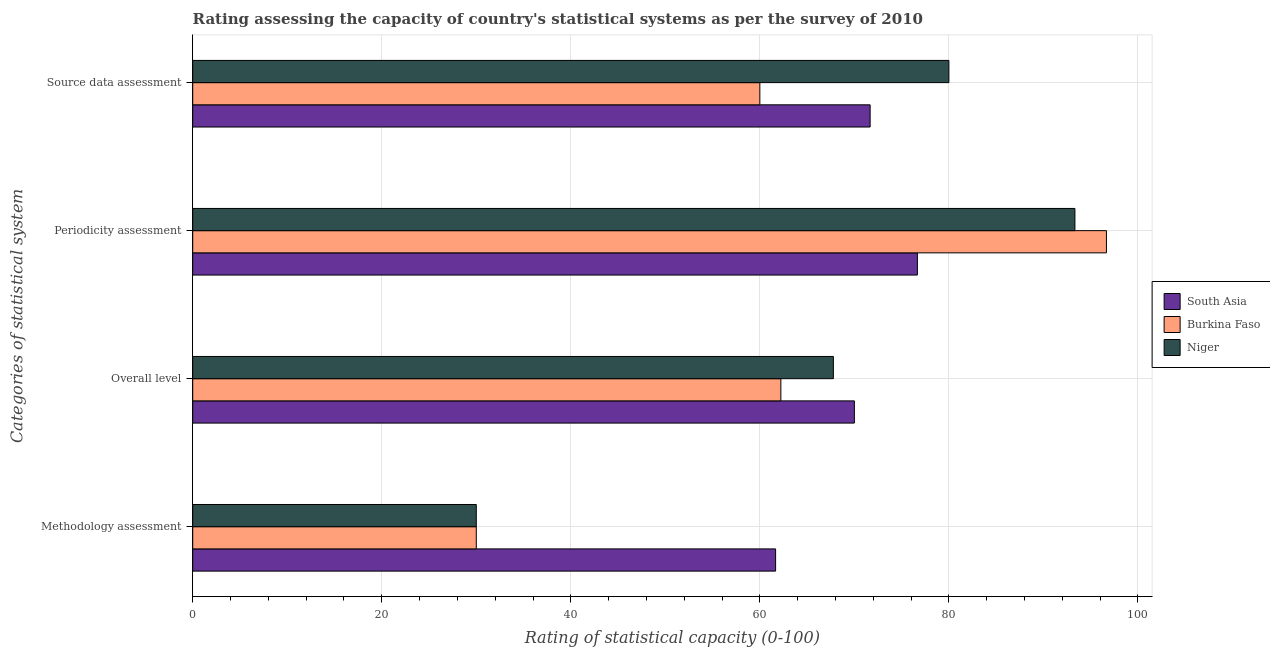How many different coloured bars are there?
Keep it short and to the point. 3. How many bars are there on the 4th tick from the bottom?
Offer a very short reply. 3. What is the label of the 3rd group of bars from the top?
Your answer should be very brief. Overall level. Across all countries, what is the maximum periodicity assessment rating?
Make the answer very short. 96.67. Across all countries, what is the minimum overall level rating?
Ensure brevity in your answer.  62.22. In which country was the overall level rating maximum?
Ensure brevity in your answer.  South Asia. In which country was the overall level rating minimum?
Provide a succinct answer. Burkina Faso. What is the total source data assessment rating in the graph?
Keep it short and to the point. 211.67. What is the difference between the overall level rating in Niger and that in South Asia?
Your answer should be very brief. -2.22. What is the difference between the overall level rating in Niger and the source data assessment rating in Burkina Faso?
Give a very brief answer. 7.78. What is the average methodology assessment rating per country?
Your answer should be very brief. 40.56. What is the difference between the methodology assessment rating and overall level rating in South Asia?
Give a very brief answer. -8.33. What is the ratio of the periodicity assessment rating in South Asia to that in Burkina Faso?
Offer a terse response. 0.79. Is the difference between the methodology assessment rating in South Asia and Niger greater than the difference between the overall level rating in South Asia and Niger?
Your answer should be compact. Yes. What is the difference between the highest and the second highest source data assessment rating?
Ensure brevity in your answer.  8.33. What is the difference between the highest and the lowest methodology assessment rating?
Offer a terse response. 31.67. Is it the case that in every country, the sum of the methodology assessment rating and periodicity assessment rating is greater than the sum of source data assessment rating and overall level rating?
Make the answer very short. No. What does the 1st bar from the top in Periodicity assessment represents?
Make the answer very short. Niger. What does the 2nd bar from the bottom in Source data assessment represents?
Provide a short and direct response. Burkina Faso. How many countries are there in the graph?
Your answer should be compact. 3. What is the difference between two consecutive major ticks on the X-axis?
Keep it short and to the point. 20. Are the values on the major ticks of X-axis written in scientific E-notation?
Ensure brevity in your answer.  No. Where does the legend appear in the graph?
Your response must be concise. Center right. How many legend labels are there?
Offer a very short reply. 3. How are the legend labels stacked?
Offer a terse response. Vertical. What is the title of the graph?
Provide a succinct answer. Rating assessing the capacity of country's statistical systems as per the survey of 2010 . Does "High income: nonOECD" appear as one of the legend labels in the graph?
Make the answer very short. No. What is the label or title of the X-axis?
Your answer should be very brief. Rating of statistical capacity (0-100). What is the label or title of the Y-axis?
Give a very brief answer. Categories of statistical system. What is the Rating of statistical capacity (0-100) in South Asia in Methodology assessment?
Your answer should be compact. 61.67. What is the Rating of statistical capacity (0-100) of Niger in Methodology assessment?
Offer a very short reply. 30. What is the Rating of statistical capacity (0-100) in South Asia in Overall level?
Give a very brief answer. 70. What is the Rating of statistical capacity (0-100) of Burkina Faso in Overall level?
Provide a short and direct response. 62.22. What is the Rating of statistical capacity (0-100) in Niger in Overall level?
Make the answer very short. 67.78. What is the Rating of statistical capacity (0-100) in South Asia in Periodicity assessment?
Offer a very short reply. 76.67. What is the Rating of statistical capacity (0-100) in Burkina Faso in Periodicity assessment?
Provide a succinct answer. 96.67. What is the Rating of statistical capacity (0-100) of Niger in Periodicity assessment?
Ensure brevity in your answer.  93.33. What is the Rating of statistical capacity (0-100) in South Asia in Source data assessment?
Your response must be concise. 71.67. What is the Rating of statistical capacity (0-100) of Burkina Faso in Source data assessment?
Give a very brief answer. 60. Across all Categories of statistical system, what is the maximum Rating of statistical capacity (0-100) of South Asia?
Provide a short and direct response. 76.67. Across all Categories of statistical system, what is the maximum Rating of statistical capacity (0-100) of Burkina Faso?
Ensure brevity in your answer.  96.67. Across all Categories of statistical system, what is the maximum Rating of statistical capacity (0-100) in Niger?
Offer a very short reply. 93.33. Across all Categories of statistical system, what is the minimum Rating of statistical capacity (0-100) of South Asia?
Give a very brief answer. 61.67. What is the total Rating of statistical capacity (0-100) of South Asia in the graph?
Ensure brevity in your answer.  280. What is the total Rating of statistical capacity (0-100) in Burkina Faso in the graph?
Give a very brief answer. 248.89. What is the total Rating of statistical capacity (0-100) of Niger in the graph?
Offer a very short reply. 271.11. What is the difference between the Rating of statistical capacity (0-100) of South Asia in Methodology assessment and that in Overall level?
Your response must be concise. -8.33. What is the difference between the Rating of statistical capacity (0-100) of Burkina Faso in Methodology assessment and that in Overall level?
Your answer should be very brief. -32.22. What is the difference between the Rating of statistical capacity (0-100) in Niger in Methodology assessment and that in Overall level?
Ensure brevity in your answer.  -37.78. What is the difference between the Rating of statistical capacity (0-100) in South Asia in Methodology assessment and that in Periodicity assessment?
Provide a succinct answer. -15. What is the difference between the Rating of statistical capacity (0-100) of Burkina Faso in Methodology assessment and that in Periodicity assessment?
Your answer should be very brief. -66.67. What is the difference between the Rating of statistical capacity (0-100) in Niger in Methodology assessment and that in Periodicity assessment?
Give a very brief answer. -63.33. What is the difference between the Rating of statistical capacity (0-100) in South Asia in Methodology assessment and that in Source data assessment?
Make the answer very short. -10. What is the difference between the Rating of statistical capacity (0-100) of South Asia in Overall level and that in Periodicity assessment?
Offer a terse response. -6.67. What is the difference between the Rating of statistical capacity (0-100) in Burkina Faso in Overall level and that in Periodicity assessment?
Keep it short and to the point. -34.44. What is the difference between the Rating of statistical capacity (0-100) in Niger in Overall level and that in Periodicity assessment?
Keep it short and to the point. -25.56. What is the difference between the Rating of statistical capacity (0-100) of South Asia in Overall level and that in Source data assessment?
Your answer should be very brief. -1.67. What is the difference between the Rating of statistical capacity (0-100) in Burkina Faso in Overall level and that in Source data assessment?
Provide a short and direct response. 2.22. What is the difference between the Rating of statistical capacity (0-100) in Niger in Overall level and that in Source data assessment?
Make the answer very short. -12.22. What is the difference between the Rating of statistical capacity (0-100) of Burkina Faso in Periodicity assessment and that in Source data assessment?
Your answer should be compact. 36.67. What is the difference between the Rating of statistical capacity (0-100) in Niger in Periodicity assessment and that in Source data assessment?
Offer a terse response. 13.33. What is the difference between the Rating of statistical capacity (0-100) in South Asia in Methodology assessment and the Rating of statistical capacity (0-100) in Burkina Faso in Overall level?
Give a very brief answer. -0.56. What is the difference between the Rating of statistical capacity (0-100) of South Asia in Methodology assessment and the Rating of statistical capacity (0-100) of Niger in Overall level?
Provide a succinct answer. -6.11. What is the difference between the Rating of statistical capacity (0-100) of Burkina Faso in Methodology assessment and the Rating of statistical capacity (0-100) of Niger in Overall level?
Your answer should be compact. -37.78. What is the difference between the Rating of statistical capacity (0-100) of South Asia in Methodology assessment and the Rating of statistical capacity (0-100) of Burkina Faso in Periodicity assessment?
Give a very brief answer. -35. What is the difference between the Rating of statistical capacity (0-100) in South Asia in Methodology assessment and the Rating of statistical capacity (0-100) in Niger in Periodicity assessment?
Provide a succinct answer. -31.67. What is the difference between the Rating of statistical capacity (0-100) of Burkina Faso in Methodology assessment and the Rating of statistical capacity (0-100) of Niger in Periodicity assessment?
Offer a very short reply. -63.33. What is the difference between the Rating of statistical capacity (0-100) in South Asia in Methodology assessment and the Rating of statistical capacity (0-100) in Burkina Faso in Source data assessment?
Make the answer very short. 1.67. What is the difference between the Rating of statistical capacity (0-100) of South Asia in Methodology assessment and the Rating of statistical capacity (0-100) of Niger in Source data assessment?
Offer a terse response. -18.33. What is the difference between the Rating of statistical capacity (0-100) of South Asia in Overall level and the Rating of statistical capacity (0-100) of Burkina Faso in Periodicity assessment?
Give a very brief answer. -26.67. What is the difference between the Rating of statistical capacity (0-100) of South Asia in Overall level and the Rating of statistical capacity (0-100) of Niger in Periodicity assessment?
Offer a terse response. -23.33. What is the difference between the Rating of statistical capacity (0-100) of Burkina Faso in Overall level and the Rating of statistical capacity (0-100) of Niger in Periodicity assessment?
Provide a succinct answer. -31.11. What is the difference between the Rating of statistical capacity (0-100) of South Asia in Overall level and the Rating of statistical capacity (0-100) of Niger in Source data assessment?
Provide a short and direct response. -10. What is the difference between the Rating of statistical capacity (0-100) of Burkina Faso in Overall level and the Rating of statistical capacity (0-100) of Niger in Source data assessment?
Your answer should be very brief. -17.78. What is the difference between the Rating of statistical capacity (0-100) in South Asia in Periodicity assessment and the Rating of statistical capacity (0-100) in Burkina Faso in Source data assessment?
Make the answer very short. 16.67. What is the difference between the Rating of statistical capacity (0-100) in South Asia in Periodicity assessment and the Rating of statistical capacity (0-100) in Niger in Source data assessment?
Make the answer very short. -3.33. What is the difference between the Rating of statistical capacity (0-100) of Burkina Faso in Periodicity assessment and the Rating of statistical capacity (0-100) of Niger in Source data assessment?
Your answer should be very brief. 16.67. What is the average Rating of statistical capacity (0-100) in South Asia per Categories of statistical system?
Offer a very short reply. 70. What is the average Rating of statistical capacity (0-100) of Burkina Faso per Categories of statistical system?
Make the answer very short. 62.22. What is the average Rating of statistical capacity (0-100) in Niger per Categories of statistical system?
Ensure brevity in your answer.  67.78. What is the difference between the Rating of statistical capacity (0-100) of South Asia and Rating of statistical capacity (0-100) of Burkina Faso in Methodology assessment?
Keep it short and to the point. 31.67. What is the difference between the Rating of statistical capacity (0-100) of South Asia and Rating of statistical capacity (0-100) of Niger in Methodology assessment?
Ensure brevity in your answer.  31.67. What is the difference between the Rating of statistical capacity (0-100) of South Asia and Rating of statistical capacity (0-100) of Burkina Faso in Overall level?
Your response must be concise. 7.78. What is the difference between the Rating of statistical capacity (0-100) of South Asia and Rating of statistical capacity (0-100) of Niger in Overall level?
Your response must be concise. 2.22. What is the difference between the Rating of statistical capacity (0-100) of Burkina Faso and Rating of statistical capacity (0-100) of Niger in Overall level?
Provide a short and direct response. -5.56. What is the difference between the Rating of statistical capacity (0-100) of South Asia and Rating of statistical capacity (0-100) of Burkina Faso in Periodicity assessment?
Offer a very short reply. -20. What is the difference between the Rating of statistical capacity (0-100) of South Asia and Rating of statistical capacity (0-100) of Niger in Periodicity assessment?
Give a very brief answer. -16.67. What is the difference between the Rating of statistical capacity (0-100) of South Asia and Rating of statistical capacity (0-100) of Burkina Faso in Source data assessment?
Keep it short and to the point. 11.67. What is the difference between the Rating of statistical capacity (0-100) of South Asia and Rating of statistical capacity (0-100) of Niger in Source data assessment?
Your answer should be compact. -8.33. What is the difference between the Rating of statistical capacity (0-100) of Burkina Faso and Rating of statistical capacity (0-100) of Niger in Source data assessment?
Your answer should be compact. -20. What is the ratio of the Rating of statistical capacity (0-100) in South Asia in Methodology assessment to that in Overall level?
Offer a very short reply. 0.88. What is the ratio of the Rating of statistical capacity (0-100) of Burkina Faso in Methodology assessment to that in Overall level?
Make the answer very short. 0.48. What is the ratio of the Rating of statistical capacity (0-100) in Niger in Methodology assessment to that in Overall level?
Offer a terse response. 0.44. What is the ratio of the Rating of statistical capacity (0-100) in South Asia in Methodology assessment to that in Periodicity assessment?
Provide a short and direct response. 0.8. What is the ratio of the Rating of statistical capacity (0-100) of Burkina Faso in Methodology assessment to that in Periodicity assessment?
Give a very brief answer. 0.31. What is the ratio of the Rating of statistical capacity (0-100) in Niger in Methodology assessment to that in Periodicity assessment?
Keep it short and to the point. 0.32. What is the ratio of the Rating of statistical capacity (0-100) in South Asia in Methodology assessment to that in Source data assessment?
Your answer should be very brief. 0.86. What is the ratio of the Rating of statistical capacity (0-100) in Burkina Faso in Methodology assessment to that in Source data assessment?
Your response must be concise. 0.5. What is the ratio of the Rating of statistical capacity (0-100) of Niger in Methodology assessment to that in Source data assessment?
Keep it short and to the point. 0.38. What is the ratio of the Rating of statistical capacity (0-100) in South Asia in Overall level to that in Periodicity assessment?
Make the answer very short. 0.91. What is the ratio of the Rating of statistical capacity (0-100) in Burkina Faso in Overall level to that in Periodicity assessment?
Your response must be concise. 0.64. What is the ratio of the Rating of statistical capacity (0-100) in Niger in Overall level to that in Periodicity assessment?
Offer a very short reply. 0.73. What is the ratio of the Rating of statistical capacity (0-100) in South Asia in Overall level to that in Source data assessment?
Give a very brief answer. 0.98. What is the ratio of the Rating of statistical capacity (0-100) of Burkina Faso in Overall level to that in Source data assessment?
Your answer should be very brief. 1.04. What is the ratio of the Rating of statistical capacity (0-100) in Niger in Overall level to that in Source data assessment?
Keep it short and to the point. 0.85. What is the ratio of the Rating of statistical capacity (0-100) of South Asia in Periodicity assessment to that in Source data assessment?
Provide a short and direct response. 1.07. What is the ratio of the Rating of statistical capacity (0-100) of Burkina Faso in Periodicity assessment to that in Source data assessment?
Provide a short and direct response. 1.61. What is the difference between the highest and the second highest Rating of statistical capacity (0-100) in Burkina Faso?
Your answer should be compact. 34.44. What is the difference between the highest and the second highest Rating of statistical capacity (0-100) of Niger?
Provide a short and direct response. 13.33. What is the difference between the highest and the lowest Rating of statistical capacity (0-100) in South Asia?
Your answer should be very brief. 15. What is the difference between the highest and the lowest Rating of statistical capacity (0-100) of Burkina Faso?
Your answer should be very brief. 66.67. What is the difference between the highest and the lowest Rating of statistical capacity (0-100) in Niger?
Offer a terse response. 63.33. 